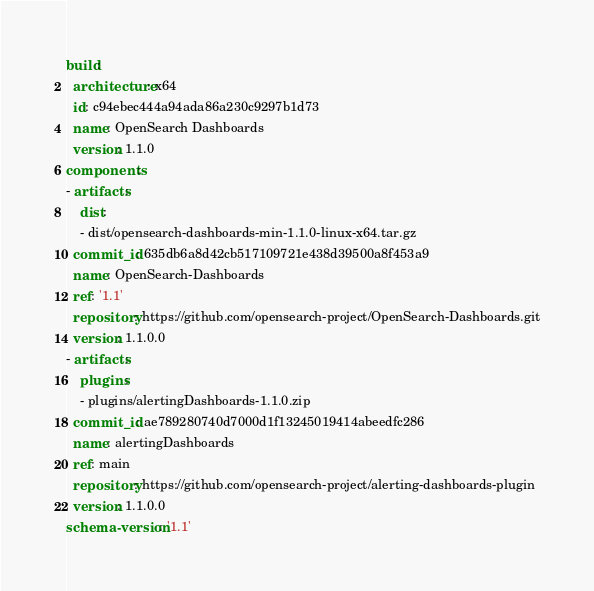<code> <loc_0><loc_0><loc_500><loc_500><_YAML_>build:
  architecture: x64
  id: c94ebec444a94ada86a230c9297b1d73
  name: OpenSearch Dashboards
  version: 1.1.0
components:
- artifacts:
    dist:
    - dist/opensearch-dashboards-min-1.1.0-linux-x64.tar.gz
  commit_id: 635db6a8d42cb517109721e438d39500a8f453a9
  name: OpenSearch-Dashboards
  ref: '1.1'
  repository: https://github.com/opensearch-project/OpenSearch-Dashboards.git
  version: 1.1.0.0
- artifacts:
    plugins:
    - plugins/alertingDashboards-1.1.0.zip
  commit_id: ae789280740d7000d1f13245019414abeedfc286
  name: alertingDashboards
  ref: main
  repository: https://github.com/opensearch-project/alerting-dashboards-plugin
  version: 1.1.0.0
schema-version: '1.1'
</code> 